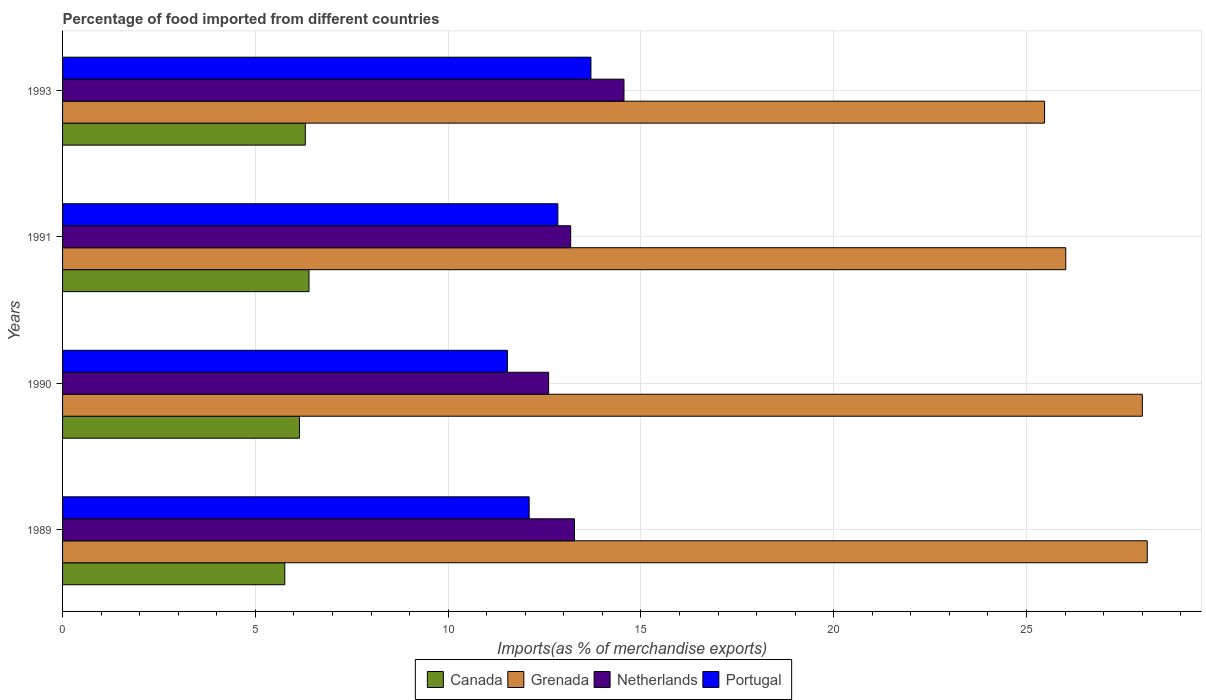How many groups of bars are there?
Provide a succinct answer. 4. Are the number of bars per tick equal to the number of legend labels?
Your response must be concise. Yes. Are the number of bars on each tick of the Y-axis equal?
Give a very brief answer. Yes. How many bars are there on the 3rd tick from the top?
Make the answer very short. 4. How many bars are there on the 3rd tick from the bottom?
Your answer should be very brief. 4. What is the label of the 2nd group of bars from the top?
Keep it short and to the point. 1991. In how many cases, is the number of bars for a given year not equal to the number of legend labels?
Your response must be concise. 0. What is the percentage of imports to different countries in Netherlands in 1989?
Your answer should be compact. 13.28. Across all years, what is the maximum percentage of imports to different countries in Portugal?
Keep it short and to the point. 13.7. Across all years, what is the minimum percentage of imports to different countries in Canada?
Ensure brevity in your answer.  5.76. In which year was the percentage of imports to different countries in Canada maximum?
Provide a succinct answer. 1991. In which year was the percentage of imports to different countries in Portugal minimum?
Give a very brief answer. 1990. What is the total percentage of imports to different countries in Grenada in the graph?
Provide a succinct answer. 107.62. What is the difference between the percentage of imports to different countries in Canada in 1989 and that in 1991?
Your answer should be compact. -0.63. What is the difference between the percentage of imports to different countries in Netherlands in 1993 and the percentage of imports to different countries in Canada in 1991?
Provide a short and direct response. 8.17. What is the average percentage of imports to different countries in Portugal per year?
Provide a short and direct response. 12.55. In the year 1989, what is the difference between the percentage of imports to different countries in Netherlands and percentage of imports to different countries in Portugal?
Keep it short and to the point. 1.18. What is the ratio of the percentage of imports to different countries in Netherlands in 1990 to that in 1993?
Your response must be concise. 0.87. Is the difference between the percentage of imports to different countries in Netherlands in 1990 and 1993 greater than the difference between the percentage of imports to different countries in Portugal in 1990 and 1993?
Your response must be concise. Yes. What is the difference between the highest and the second highest percentage of imports to different countries in Canada?
Provide a short and direct response. 0.1. What is the difference between the highest and the lowest percentage of imports to different countries in Grenada?
Offer a terse response. 2.66. In how many years, is the percentage of imports to different countries in Canada greater than the average percentage of imports to different countries in Canada taken over all years?
Your response must be concise. 2. What does the 4th bar from the top in 1989 represents?
Your response must be concise. Canada. Are the values on the major ticks of X-axis written in scientific E-notation?
Offer a very short reply. No. Where does the legend appear in the graph?
Give a very brief answer. Bottom center. How many legend labels are there?
Make the answer very short. 4. How are the legend labels stacked?
Give a very brief answer. Horizontal. What is the title of the graph?
Give a very brief answer. Percentage of food imported from different countries. What is the label or title of the X-axis?
Make the answer very short. Imports(as % of merchandise exports). What is the Imports(as % of merchandise exports) in Canada in 1989?
Give a very brief answer. 5.76. What is the Imports(as % of merchandise exports) in Grenada in 1989?
Offer a terse response. 28.13. What is the Imports(as % of merchandise exports) of Netherlands in 1989?
Offer a terse response. 13.28. What is the Imports(as % of merchandise exports) of Portugal in 1989?
Offer a very short reply. 12.1. What is the Imports(as % of merchandise exports) of Canada in 1990?
Your answer should be very brief. 6.14. What is the Imports(as % of merchandise exports) in Grenada in 1990?
Provide a short and direct response. 28. What is the Imports(as % of merchandise exports) of Netherlands in 1990?
Provide a succinct answer. 12.61. What is the Imports(as % of merchandise exports) in Portugal in 1990?
Offer a very short reply. 11.54. What is the Imports(as % of merchandise exports) of Canada in 1991?
Keep it short and to the point. 6.39. What is the Imports(as % of merchandise exports) of Grenada in 1991?
Your answer should be compact. 26.02. What is the Imports(as % of merchandise exports) of Netherlands in 1991?
Your answer should be very brief. 13.18. What is the Imports(as % of merchandise exports) in Portugal in 1991?
Offer a terse response. 12.85. What is the Imports(as % of merchandise exports) of Canada in 1993?
Your response must be concise. 6.3. What is the Imports(as % of merchandise exports) of Grenada in 1993?
Ensure brevity in your answer.  25.47. What is the Imports(as % of merchandise exports) of Netherlands in 1993?
Ensure brevity in your answer.  14.56. What is the Imports(as % of merchandise exports) in Portugal in 1993?
Ensure brevity in your answer.  13.7. Across all years, what is the maximum Imports(as % of merchandise exports) of Canada?
Your answer should be compact. 6.39. Across all years, what is the maximum Imports(as % of merchandise exports) in Grenada?
Offer a very short reply. 28.13. Across all years, what is the maximum Imports(as % of merchandise exports) of Netherlands?
Provide a short and direct response. 14.56. Across all years, what is the maximum Imports(as % of merchandise exports) in Portugal?
Your answer should be very brief. 13.7. Across all years, what is the minimum Imports(as % of merchandise exports) in Canada?
Offer a very short reply. 5.76. Across all years, what is the minimum Imports(as % of merchandise exports) of Grenada?
Offer a very short reply. 25.47. Across all years, what is the minimum Imports(as % of merchandise exports) of Netherlands?
Give a very brief answer. 12.61. Across all years, what is the minimum Imports(as % of merchandise exports) in Portugal?
Your answer should be very brief. 11.54. What is the total Imports(as % of merchandise exports) of Canada in the graph?
Give a very brief answer. 24.59. What is the total Imports(as % of merchandise exports) of Grenada in the graph?
Make the answer very short. 107.62. What is the total Imports(as % of merchandise exports) of Netherlands in the graph?
Offer a very short reply. 53.62. What is the total Imports(as % of merchandise exports) of Portugal in the graph?
Offer a terse response. 50.19. What is the difference between the Imports(as % of merchandise exports) of Canada in 1989 and that in 1990?
Offer a very short reply. -0.38. What is the difference between the Imports(as % of merchandise exports) in Grenada in 1989 and that in 1990?
Your answer should be very brief. 0.13. What is the difference between the Imports(as % of merchandise exports) in Netherlands in 1989 and that in 1990?
Ensure brevity in your answer.  0.67. What is the difference between the Imports(as % of merchandise exports) of Portugal in 1989 and that in 1990?
Provide a short and direct response. 0.56. What is the difference between the Imports(as % of merchandise exports) in Canada in 1989 and that in 1991?
Provide a short and direct response. -0.63. What is the difference between the Imports(as % of merchandise exports) in Grenada in 1989 and that in 1991?
Ensure brevity in your answer.  2.11. What is the difference between the Imports(as % of merchandise exports) of Netherlands in 1989 and that in 1991?
Offer a terse response. 0.1. What is the difference between the Imports(as % of merchandise exports) of Portugal in 1989 and that in 1991?
Make the answer very short. -0.74. What is the difference between the Imports(as % of merchandise exports) of Canada in 1989 and that in 1993?
Offer a terse response. -0.53. What is the difference between the Imports(as % of merchandise exports) of Grenada in 1989 and that in 1993?
Provide a succinct answer. 2.66. What is the difference between the Imports(as % of merchandise exports) in Netherlands in 1989 and that in 1993?
Your response must be concise. -1.28. What is the difference between the Imports(as % of merchandise exports) of Portugal in 1989 and that in 1993?
Offer a terse response. -1.6. What is the difference between the Imports(as % of merchandise exports) of Canada in 1990 and that in 1991?
Your answer should be very brief. -0.25. What is the difference between the Imports(as % of merchandise exports) in Grenada in 1990 and that in 1991?
Your answer should be compact. 1.98. What is the difference between the Imports(as % of merchandise exports) in Netherlands in 1990 and that in 1991?
Keep it short and to the point. -0.57. What is the difference between the Imports(as % of merchandise exports) of Portugal in 1990 and that in 1991?
Ensure brevity in your answer.  -1.31. What is the difference between the Imports(as % of merchandise exports) in Canada in 1990 and that in 1993?
Provide a short and direct response. -0.15. What is the difference between the Imports(as % of merchandise exports) of Grenada in 1990 and that in 1993?
Your response must be concise. 2.54. What is the difference between the Imports(as % of merchandise exports) of Netherlands in 1990 and that in 1993?
Your answer should be compact. -1.95. What is the difference between the Imports(as % of merchandise exports) of Portugal in 1990 and that in 1993?
Your answer should be very brief. -2.17. What is the difference between the Imports(as % of merchandise exports) of Canada in 1991 and that in 1993?
Your answer should be very brief. 0.1. What is the difference between the Imports(as % of merchandise exports) of Grenada in 1991 and that in 1993?
Ensure brevity in your answer.  0.55. What is the difference between the Imports(as % of merchandise exports) of Netherlands in 1991 and that in 1993?
Make the answer very short. -1.38. What is the difference between the Imports(as % of merchandise exports) of Portugal in 1991 and that in 1993?
Give a very brief answer. -0.86. What is the difference between the Imports(as % of merchandise exports) of Canada in 1989 and the Imports(as % of merchandise exports) of Grenada in 1990?
Your response must be concise. -22.24. What is the difference between the Imports(as % of merchandise exports) in Canada in 1989 and the Imports(as % of merchandise exports) in Netherlands in 1990?
Keep it short and to the point. -6.84. What is the difference between the Imports(as % of merchandise exports) of Canada in 1989 and the Imports(as % of merchandise exports) of Portugal in 1990?
Provide a short and direct response. -5.77. What is the difference between the Imports(as % of merchandise exports) in Grenada in 1989 and the Imports(as % of merchandise exports) in Netherlands in 1990?
Offer a very short reply. 15.53. What is the difference between the Imports(as % of merchandise exports) in Grenada in 1989 and the Imports(as % of merchandise exports) in Portugal in 1990?
Keep it short and to the point. 16.59. What is the difference between the Imports(as % of merchandise exports) in Netherlands in 1989 and the Imports(as % of merchandise exports) in Portugal in 1990?
Offer a terse response. 1.74. What is the difference between the Imports(as % of merchandise exports) of Canada in 1989 and the Imports(as % of merchandise exports) of Grenada in 1991?
Offer a very short reply. -20.26. What is the difference between the Imports(as % of merchandise exports) in Canada in 1989 and the Imports(as % of merchandise exports) in Netherlands in 1991?
Ensure brevity in your answer.  -7.41. What is the difference between the Imports(as % of merchandise exports) of Canada in 1989 and the Imports(as % of merchandise exports) of Portugal in 1991?
Keep it short and to the point. -7.08. What is the difference between the Imports(as % of merchandise exports) of Grenada in 1989 and the Imports(as % of merchandise exports) of Netherlands in 1991?
Provide a succinct answer. 14.95. What is the difference between the Imports(as % of merchandise exports) in Grenada in 1989 and the Imports(as % of merchandise exports) in Portugal in 1991?
Your response must be concise. 15.29. What is the difference between the Imports(as % of merchandise exports) in Netherlands in 1989 and the Imports(as % of merchandise exports) in Portugal in 1991?
Keep it short and to the point. 0.43. What is the difference between the Imports(as % of merchandise exports) in Canada in 1989 and the Imports(as % of merchandise exports) in Grenada in 1993?
Your answer should be compact. -19.71. What is the difference between the Imports(as % of merchandise exports) of Canada in 1989 and the Imports(as % of merchandise exports) of Netherlands in 1993?
Ensure brevity in your answer.  -8.8. What is the difference between the Imports(as % of merchandise exports) in Canada in 1989 and the Imports(as % of merchandise exports) in Portugal in 1993?
Make the answer very short. -7.94. What is the difference between the Imports(as % of merchandise exports) in Grenada in 1989 and the Imports(as % of merchandise exports) in Netherlands in 1993?
Your answer should be very brief. 13.57. What is the difference between the Imports(as % of merchandise exports) in Grenada in 1989 and the Imports(as % of merchandise exports) in Portugal in 1993?
Provide a succinct answer. 14.43. What is the difference between the Imports(as % of merchandise exports) of Netherlands in 1989 and the Imports(as % of merchandise exports) of Portugal in 1993?
Give a very brief answer. -0.43. What is the difference between the Imports(as % of merchandise exports) of Canada in 1990 and the Imports(as % of merchandise exports) of Grenada in 1991?
Make the answer very short. -19.88. What is the difference between the Imports(as % of merchandise exports) of Canada in 1990 and the Imports(as % of merchandise exports) of Netherlands in 1991?
Offer a terse response. -7.03. What is the difference between the Imports(as % of merchandise exports) in Canada in 1990 and the Imports(as % of merchandise exports) in Portugal in 1991?
Provide a short and direct response. -6.7. What is the difference between the Imports(as % of merchandise exports) in Grenada in 1990 and the Imports(as % of merchandise exports) in Netherlands in 1991?
Ensure brevity in your answer.  14.83. What is the difference between the Imports(as % of merchandise exports) of Grenada in 1990 and the Imports(as % of merchandise exports) of Portugal in 1991?
Provide a succinct answer. 15.16. What is the difference between the Imports(as % of merchandise exports) of Netherlands in 1990 and the Imports(as % of merchandise exports) of Portugal in 1991?
Ensure brevity in your answer.  -0.24. What is the difference between the Imports(as % of merchandise exports) in Canada in 1990 and the Imports(as % of merchandise exports) in Grenada in 1993?
Your response must be concise. -19.33. What is the difference between the Imports(as % of merchandise exports) of Canada in 1990 and the Imports(as % of merchandise exports) of Netherlands in 1993?
Your answer should be compact. -8.42. What is the difference between the Imports(as % of merchandise exports) of Canada in 1990 and the Imports(as % of merchandise exports) of Portugal in 1993?
Your answer should be compact. -7.56. What is the difference between the Imports(as % of merchandise exports) of Grenada in 1990 and the Imports(as % of merchandise exports) of Netherlands in 1993?
Make the answer very short. 13.44. What is the difference between the Imports(as % of merchandise exports) of Grenada in 1990 and the Imports(as % of merchandise exports) of Portugal in 1993?
Provide a short and direct response. 14.3. What is the difference between the Imports(as % of merchandise exports) of Netherlands in 1990 and the Imports(as % of merchandise exports) of Portugal in 1993?
Offer a terse response. -1.1. What is the difference between the Imports(as % of merchandise exports) in Canada in 1991 and the Imports(as % of merchandise exports) in Grenada in 1993?
Make the answer very short. -19.08. What is the difference between the Imports(as % of merchandise exports) of Canada in 1991 and the Imports(as % of merchandise exports) of Netherlands in 1993?
Offer a terse response. -8.17. What is the difference between the Imports(as % of merchandise exports) in Canada in 1991 and the Imports(as % of merchandise exports) in Portugal in 1993?
Your answer should be compact. -7.31. What is the difference between the Imports(as % of merchandise exports) in Grenada in 1991 and the Imports(as % of merchandise exports) in Netherlands in 1993?
Give a very brief answer. 11.46. What is the difference between the Imports(as % of merchandise exports) of Grenada in 1991 and the Imports(as % of merchandise exports) of Portugal in 1993?
Your answer should be very brief. 12.32. What is the difference between the Imports(as % of merchandise exports) in Netherlands in 1991 and the Imports(as % of merchandise exports) in Portugal in 1993?
Give a very brief answer. -0.53. What is the average Imports(as % of merchandise exports) of Canada per year?
Your answer should be very brief. 6.15. What is the average Imports(as % of merchandise exports) in Grenada per year?
Your response must be concise. 26.91. What is the average Imports(as % of merchandise exports) of Netherlands per year?
Ensure brevity in your answer.  13.41. What is the average Imports(as % of merchandise exports) of Portugal per year?
Give a very brief answer. 12.55. In the year 1989, what is the difference between the Imports(as % of merchandise exports) of Canada and Imports(as % of merchandise exports) of Grenada?
Your answer should be compact. -22.37. In the year 1989, what is the difference between the Imports(as % of merchandise exports) of Canada and Imports(as % of merchandise exports) of Netherlands?
Give a very brief answer. -7.51. In the year 1989, what is the difference between the Imports(as % of merchandise exports) of Canada and Imports(as % of merchandise exports) of Portugal?
Ensure brevity in your answer.  -6.34. In the year 1989, what is the difference between the Imports(as % of merchandise exports) of Grenada and Imports(as % of merchandise exports) of Netherlands?
Keep it short and to the point. 14.85. In the year 1989, what is the difference between the Imports(as % of merchandise exports) in Grenada and Imports(as % of merchandise exports) in Portugal?
Your answer should be compact. 16.03. In the year 1989, what is the difference between the Imports(as % of merchandise exports) of Netherlands and Imports(as % of merchandise exports) of Portugal?
Offer a terse response. 1.18. In the year 1990, what is the difference between the Imports(as % of merchandise exports) in Canada and Imports(as % of merchandise exports) in Grenada?
Keep it short and to the point. -21.86. In the year 1990, what is the difference between the Imports(as % of merchandise exports) of Canada and Imports(as % of merchandise exports) of Netherlands?
Ensure brevity in your answer.  -6.46. In the year 1990, what is the difference between the Imports(as % of merchandise exports) in Canada and Imports(as % of merchandise exports) in Portugal?
Your answer should be very brief. -5.39. In the year 1990, what is the difference between the Imports(as % of merchandise exports) in Grenada and Imports(as % of merchandise exports) in Netherlands?
Make the answer very short. 15.4. In the year 1990, what is the difference between the Imports(as % of merchandise exports) in Grenada and Imports(as % of merchandise exports) in Portugal?
Provide a succinct answer. 16.47. In the year 1990, what is the difference between the Imports(as % of merchandise exports) of Netherlands and Imports(as % of merchandise exports) of Portugal?
Provide a short and direct response. 1.07. In the year 1991, what is the difference between the Imports(as % of merchandise exports) of Canada and Imports(as % of merchandise exports) of Grenada?
Provide a succinct answer. -19.63. In the year 1991, what is the difference between the Imports(as % of merchandise exports) in Canada and Imports(as % of merchandise exports) in Netherlands?
Offer a terse response. -6.79. In the year 1991, what is the difference between the Imports(as % of merchandise exports) of Canada and Imports(as % of merchandise exports) of Portugal?
Make the answer very short. -6.45. In the year 1991, what is the difference between the Imports(as % of merchandise exports) of Grenada and Imports(as % of merchandise exports) of Netherlands?
Ensure brevity in your answer.  12.84. In the year 1991, what is the difference between the Imports(as % of merchandise exports) of Grenada and Imports(as % of merchandise exports) of Portugal?
Make the answer very short. 13.17. In the year 1991, what is the difference between the Imports(as % of merchandise exports) in Netherlands and Imports(as % of merchandise exports) in Portugal?
Your answer should be very brief. 0.33. In the year 1993, what is the difference between the Imports(as % of merchandise exports) in Canada and Imports(as % of merchandise exports) in Grenada?
Offer a very short reply. -19.17. In the year 1993, what is the difference between the Imports(as % of merchandise exports) in Canada and Imports(as % of merchandise exports) in Netherlands?
Give a very brief answer. -8.27. In the year 1993, what is the difference between the Imports(as % of merchandise exports) in Canada and Imports(as % of merchandise exports) in Portugal?
Your answer should be compact. -7.41. In the year 1993, what is the difference between the Imports(as % of merchandise exports) in Grenada and Imports(as % of merchandise exports) in Netherlands?
Make the answer very short. 10.91. In the year 1993, what is the difference between the Imports(as % of merchandise exports) in Grenada and Imports(as % of merchandise exports) in Portugal?
Give a very brief answer. 11.77. In the year 1993, what is the difference between the Imports(as % of merchandise exports) of Netherlands and Imports(as % of merchandise exports) of Portugal?
Give a very brief answer. 0.86. What is the ratio of the Imports(as % of merchandise exports) of Canada in 1989 to that in 1990?
Keep it short and to the point. 0.94. What is the ratio of the Imports(as % of merchandise exports) of Netherlands in 1989 to that in 1990?
Your answer should be compact. 1.05. What is the ratio of the Imports(as % of merchandise exports) of Portugal in 1989 to that in 1990?
Offer a terse response. 1.05. What is the ratio of the Imports(as % of merchandise exports) in Canada in 1989 to that in 1991?
Keep it short and to the point. 0.9. What is the ratio of the Imports(as % of merchandise exports) in Grenada in 1989 to that in 1991?
Your answer should be compact. 1.08. What is the ratio of the Imports(as % of merchandise exports) in Netherlands in 1989 to that in 1991?
Offer a terse response. 1.01. What is the ratio of the Imports(as % of merchandise exports) in Portugal in 1989 to that in 1991?
Offer a terse response. 0.94. What is the ratio of the Imports(as % of merchandise exports) of Canada in 1989 to that in 1993?
Offer a terse response. 0.92. What is the ratio of the Imports(as % of merchandise exports) in Grenada in 1989 to that in 1993?
Provide a short and direct response. 1.1. What is the ratio of the Imports(as % of merchandise exports) of Netherlands in 1989 to that in 1993?
Make the answer very short. 0.91. What is the ratio of the Imports(as % of merchandise exports) of Portugal in 1989 to that in 1993?
Give a very brief answer. 0.88. What is the ratio of the Imports(as % of merchandise exports) in Canada in 1990 to that in 1991?
Offer a very short reply. 0.96. What is the ratio of the Imports(as % of merchandise exports) of Grenada in 1990 to that in 1991?
Ensure brevity in your answer.  1.08. What is the ratio of the Imports(as % of merchandise exports) of Netherlands in 1990 to that in 1991?
Keep it short and to the point. 0.96. What is the ratio of the Imports(as % of merchandise exports) of Portugal in 1990 to that in 1991?
Provide a short and direct response. 0.9. What is the ratio of the Imports(as % of merchandise exports) in Canada in 1990 to that in 1993?
Offer a very short reply. 0.98. What is the ratio of the Imports(as % of merchandise exports) of Grenada in 1990 to that in 1993?
Your response must be concise. 1.1. What is the ratio of the Imports(as % of merchandise exports) in Netherlands in 1990 to that in 1993?
Your answer should be compact. 0.87. What is the ratio of the Imports(as % of merchandise exports) in Portugal in 1990 to that in 1993?
Your answer should be compact. 0.84. What is the ratio of the Imports(as % of merchandise exports) in Canada in 1991 to that in 1993?
Your response must be concise. 1.02. What is the ratio of the Imports(as % of merchandise exports) in Grenada in 1991 to that in 1993?
Give a very brief answer. 1.02. What is the ratio of the Imports(as % of merchandise exports) in Netherlands in 1991 to that in 1993?
Your response must be concise. 0.91. What is the ratio of the Imports(as % of merchandise exports) in Portugal in 1991 to that in 1993?
Your answer should be very brief. 0.94. What is the difference between the highest and the second highest Imports(as % of merchandise exports) of Canada?
Make the answer very short. 0.1. What is the difference between the highest and the second highest Imports(as % of merchandise exports) of Grenada?
Keep it short and to the point. 0.13. What is the difference between the highest and the second highest Imports(as % of merchandise exports) in Netherlands?
Your answer should be very brief. 1.28. What is the difference between the highest and the second highest Imports(as % of merchandise exports) in Portugal?
Ensure brevity in your answer.  0.86. What is the difference between the highest and the lowest Imports(as % of merchandise exports) in Canada?
Your response must be concise. 0.63. What is the difference between the highest and the lowest Imports(as % of merchandise exports) in Grenada?
Keep it short and to the point. 2.66. What is the difference between the highest and the lowest Imports(as % of merchandise exports) of Netherlands?
Keep it short and to the point. 1.95. What is the difference between the highest and the lowest Imports(as % of merchandise exports) in Portugal?
Offer a very short reply. 2.17. 